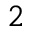<formula> <loc_0><loc_0><loc_500><loc_500>_ { 2 }</formula> 